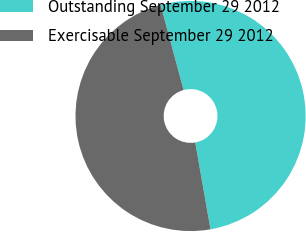Convert chart to OTSL. <chart><loc_0><loc_0><loc_500><loc_500><pie_chart><fcel>Outstanding September 29 2012<fcel>Exercisable September 29 2012<nl><fcel>51.42%<fcel>48.58%<nl></chart> 